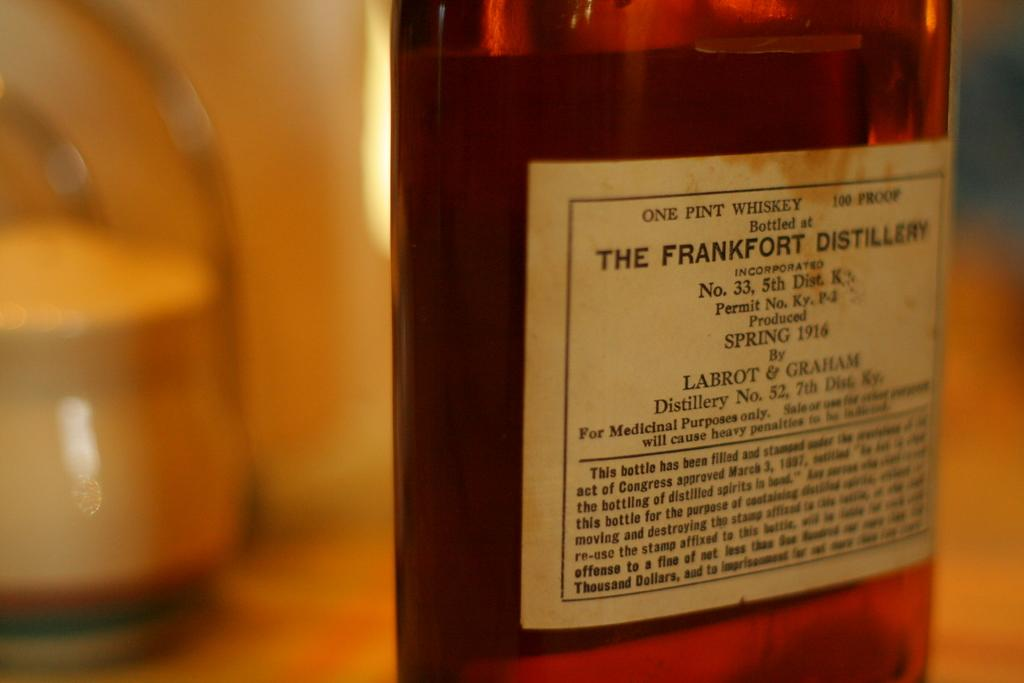<image>
Create a compact narrative representing the image presented. One Pint Whiskey of the Frankfort Distillery No, 33 5th District. 